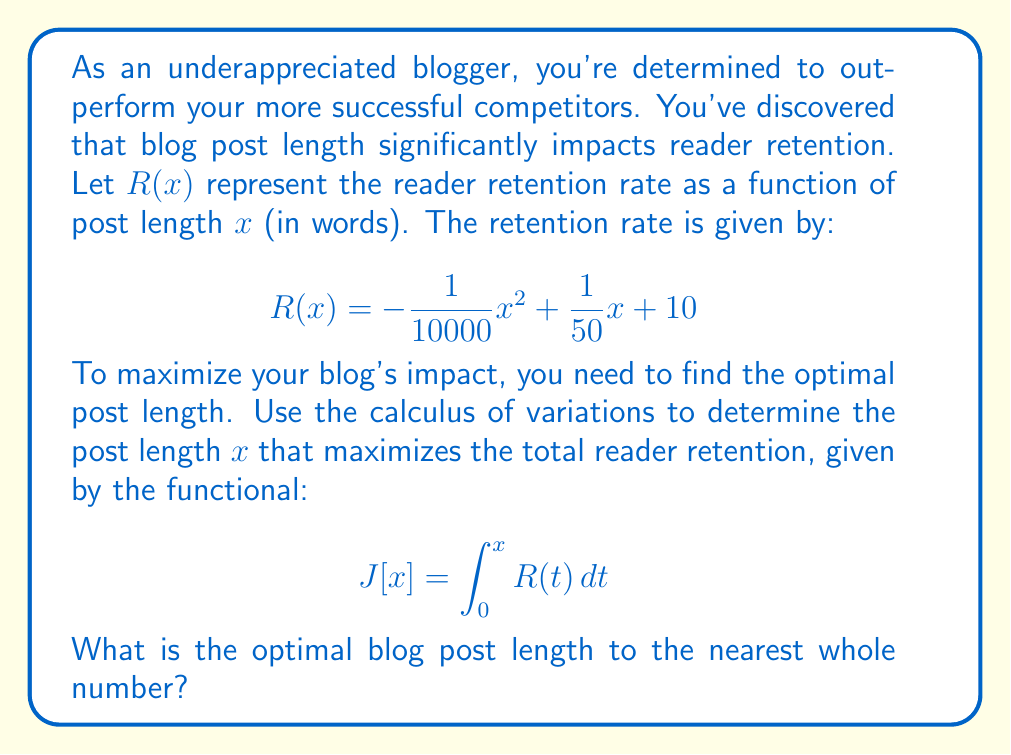Give your solution to this math problem. To solve this problem, we'll use the Euler-Lagrange equation from the calculus of variations. However, in this case, our functional doesn't depend on the derivative of $x$, so we can simply maximize the integrand $R(x)$.

1) First, let's find the critical points of $R(x)$ by taking its derivative and setting it to zero:

   $$R'(x) = -\frac{1}{5000}x + \frac{1}{50} = 0$$

2) Solving for $x$:

   $$-\frac{1}{5000}x + \frac{1}{50} = 0$$
   $$-\frac{1}{5000}x = -\frac{1}{50}$$
   $$x = 100$$

3) To confirm this is a maximum, we can check the second derivative:

   $$R''(x) = -\frac{1}{5000} < 0$$

   Since $R''(x)$ is negative, the critical point is indeed a maximum.

4) Therefore, the optimal blog post length is 100 words.

5) To verify, we can calculate $R(x)$ for $x = 99$, $100$, and $101$:

   $$R(99) \approx 11.9801$$
   $$R(100) = 12$$
   $$R(101) \approx 11.9801$$

   This confirms that 100 words gives the maximum retention rate.
Answer: 100 words 